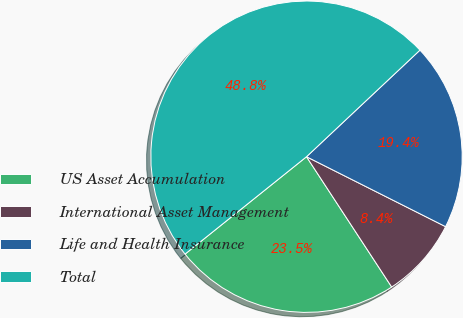Convert chart to OTSL. <chart><loc_0><loc_0><loc_500><loc_500><pie_chart><fcel>US Asset Accumulation<fcel>International Asset Management<fcel>Life and Health Insurance<fcel>Total<nl><fcel>23.46%<fcel>8.37%<fcel>19.42%<fcel>48.75%<nl></chart> 